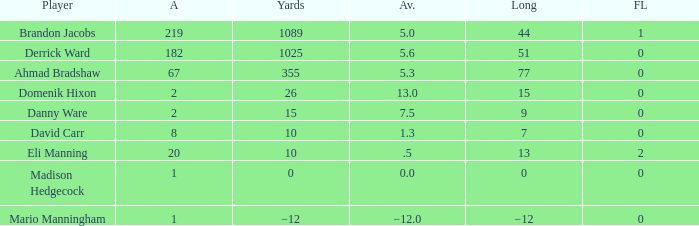What is Domenik Hixon's average rush? 13.0. 